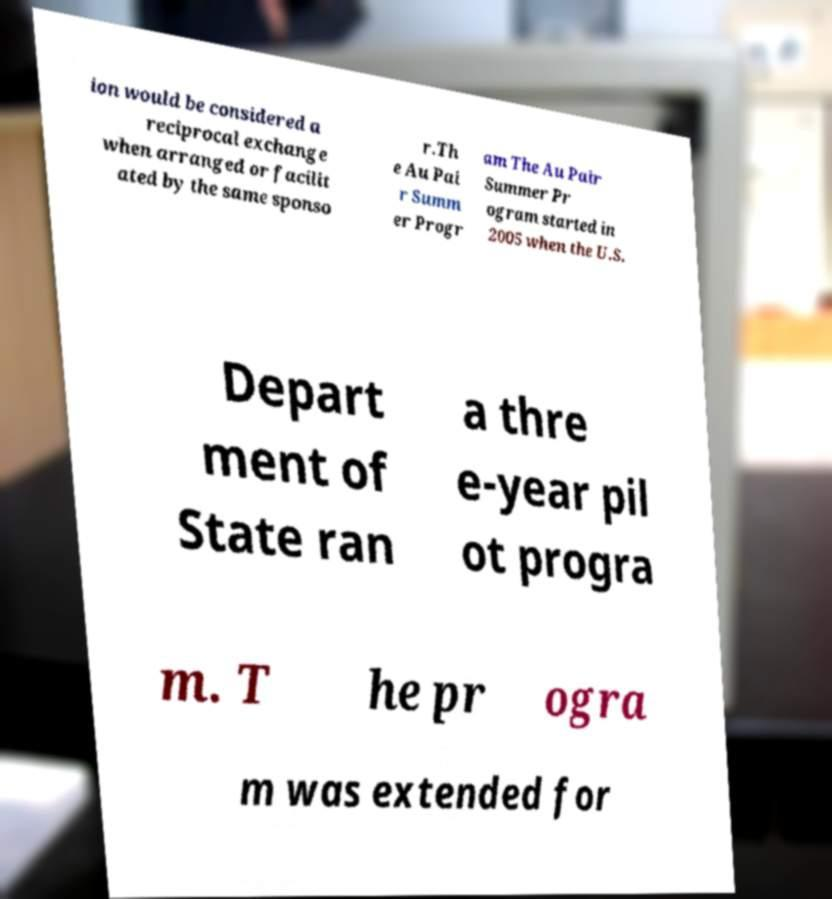Could you assist in decoding the text presented in this image and type it out clearly? ion would be considered a reciprocal exchange when arranged or facilit ated by the same sponso r.Th e Au Pai r Summ er Progr am The Au Pair Summer Pr ogram started in 2005 when the U.S. Depart ment of State ran a thre e-year pil ot progra m. T he pr ogra m was extended for 